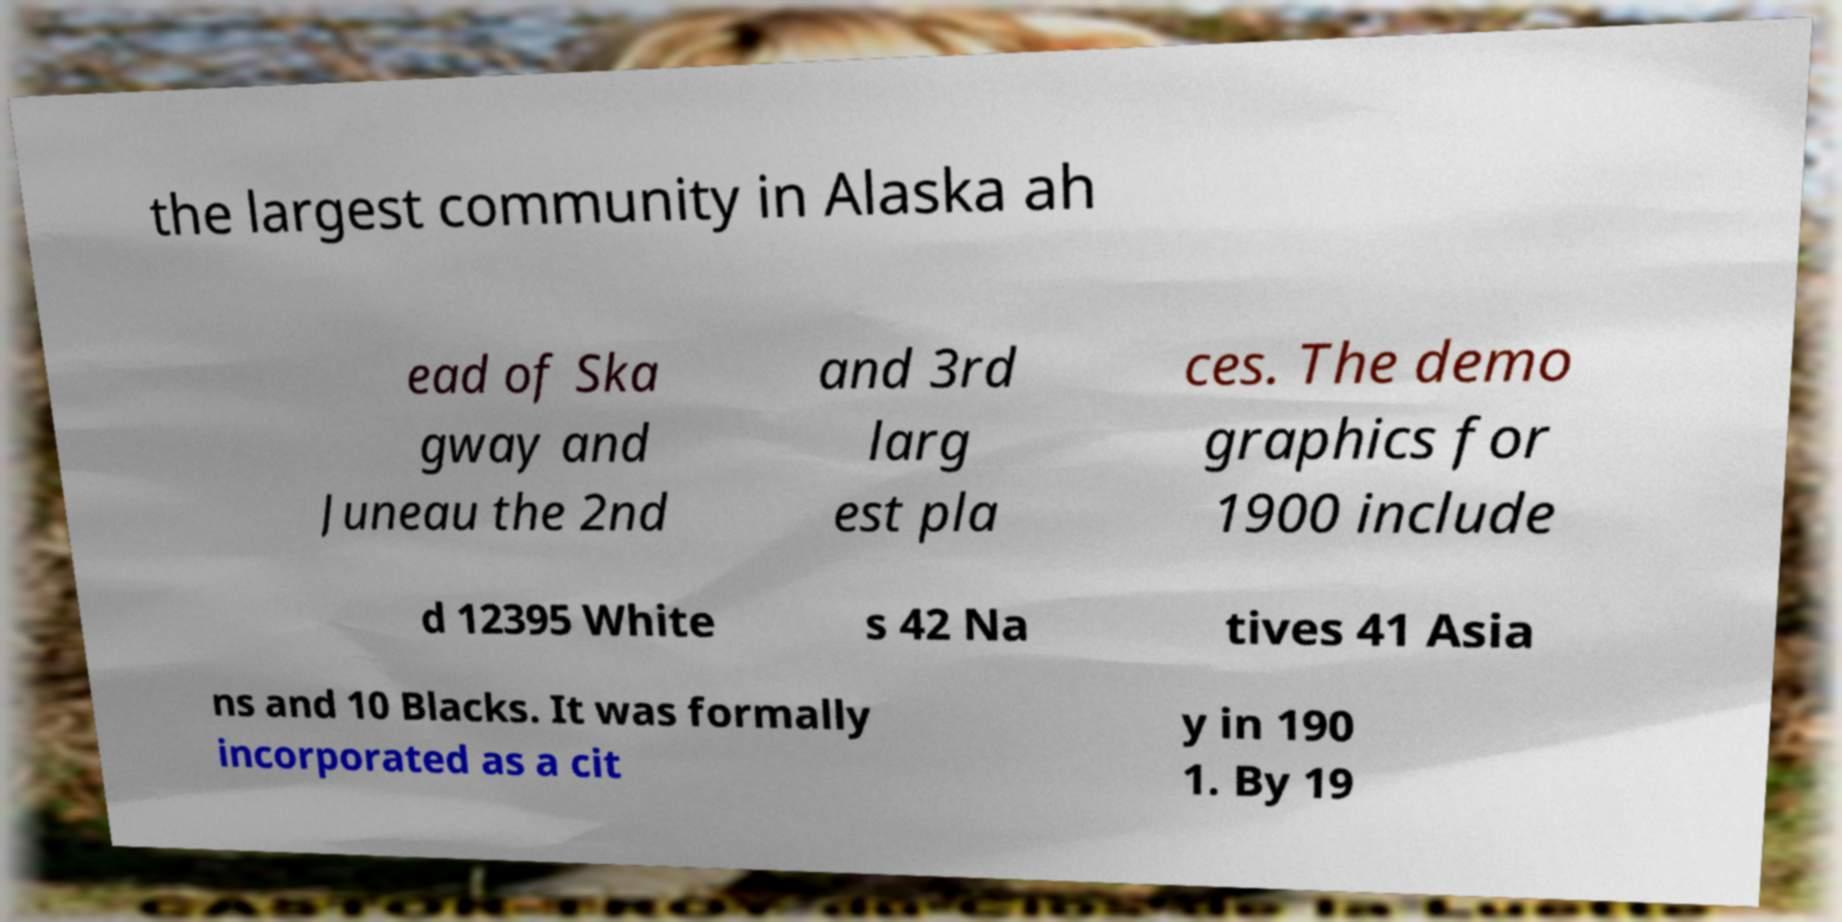Could you assist in decoding the text presented in this image and type it out clearly? the largest community in Alaska ah ead of Ska gway and Juneau the 2nd and 3rd larg est pla ces. The demo graphics for 1900 include d 12395 White s 42 Na tives 41 Asia ns and 10 Blacks. It was formally incorporated as a cit y in 190 1. By 19 